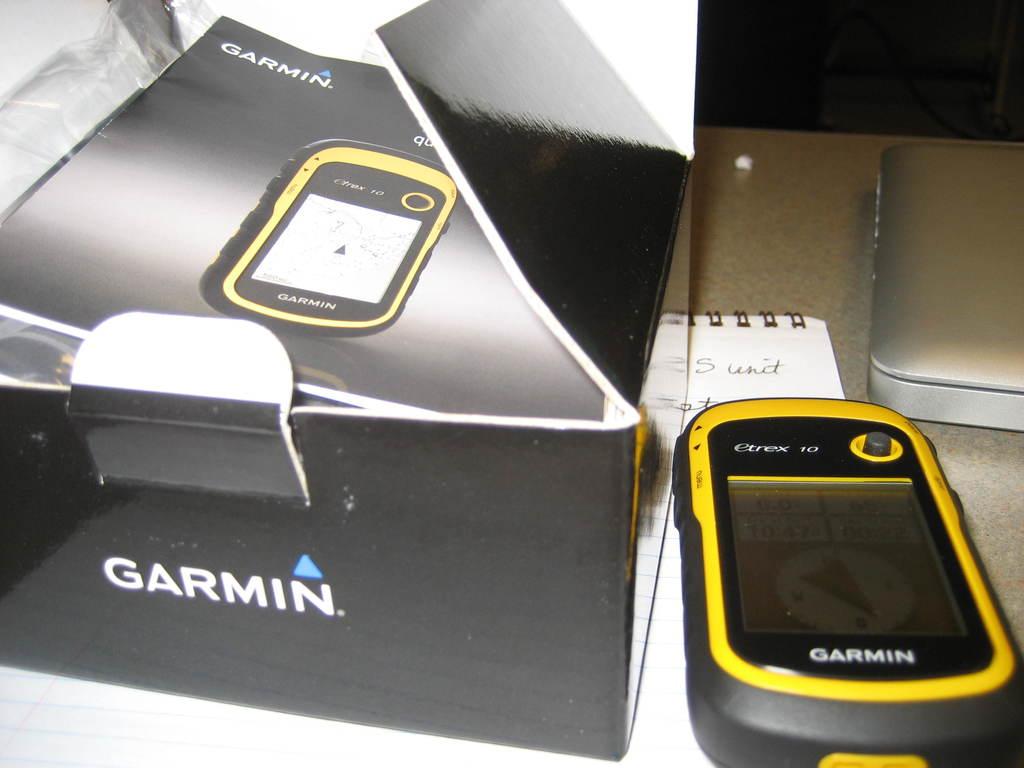What is the brand of gps?
Your response must be concise. Garmin. 